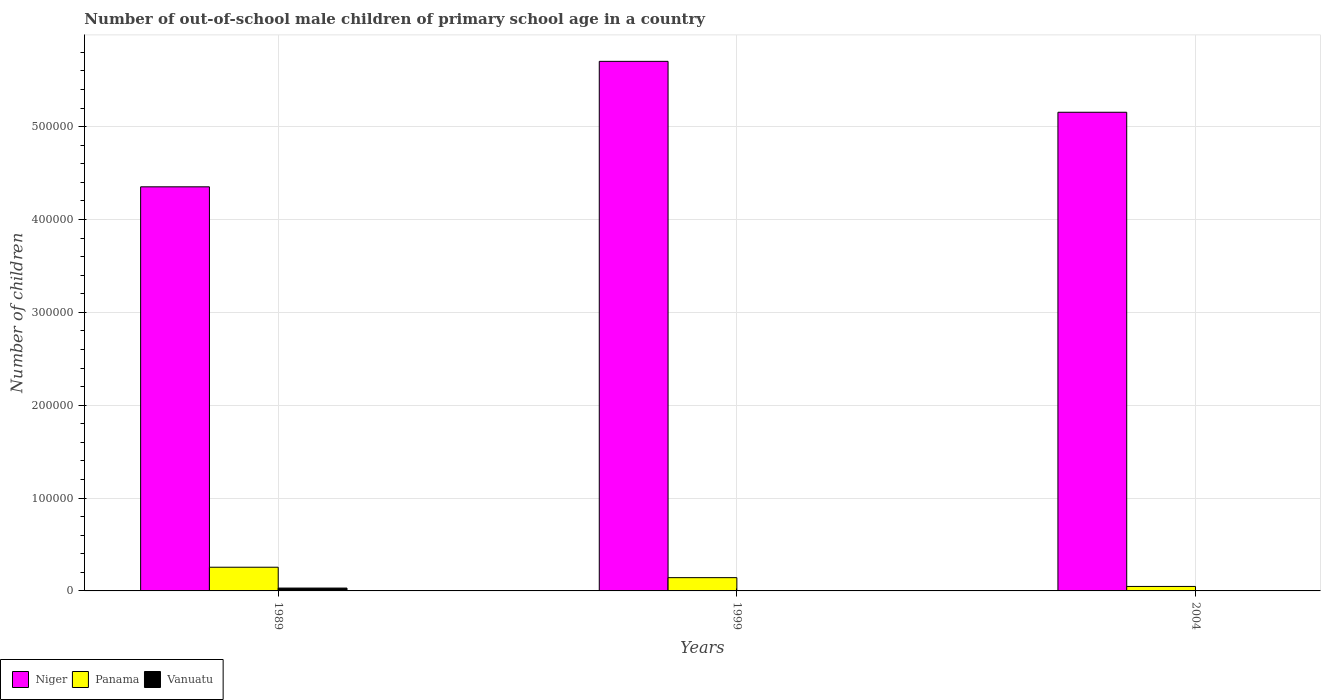How many different coloured bars are there?
Your answer should be compact. 3. How many groups of bars are there?
Offer a terse response. 3. Are the number of bars per tick equal to the number of legend labels?
Provide a succinct answer. Yes. How many bars are there on the 3rd tick from the left?
Your answer should be very brief. 3. In how many cases, is the number of bars for a given year not equal to the number of legend labels?
Keep it short and to the point. 0. What is the number of out-of-school male children in Panama in 1989?
Your answer should be compact. 2.55e+04. Across all years, what is the maximum number of out-of-school male children in Panama?
Provide a succinct answer. 2.55e+04. Across all years, what is the minimum number of out-of-school male children in Panama?
Provide a succinct answer. 4823. In which year was the number of out-of-school male children in Panama maximum?
Offer a terse response. 1989. What is the total number of out-of-school male children in Vanuatu in the graph?
Your answer should be compact. 3685. What is the difference between the number of out-of-school male children in Panama in 1989 and that in 1999?
Offer a terse response. 1.12e+04. What is the difference between the number of out-of-school male children in Niger in 1999 and the number of out-of-school male children in Vanuatu in 2004?
Offer a terse response. 5.70e+05. What is the average number of out-of-school male children in Vanuatu per year?
Give a very brief answer. 1228.33. In the year 2004, what is the difference between the number of out-of-school male children in Niger and number of out-of-school male children in Vanuatu?
Offer a very short reply. 5.15e+05. In how many years, is the number of out-of-school male children in Panama greater than 540000?
Give a very brief answer. 0. What is the ratio of the number of out-of-school male children in Vanuatu in 1999 to that in 2004?
Your response must be concise. 0.74. Is the difference between the number of out-of-school male children in Niger in 1999 and 2004 greater than the difference between the number of out-of-school male children in Vanuatu in 1999 and 2004?
Your response must be concise. Yes. What is the difference between the highest and the second highest number of out-of-school male children in Niger?
Keep it short and to the point. 5.48e+04. What is the difference between the highest and the lowest number of out-of-school male children in Niger?
Provide a short and direct response. 1.35e+05. What does the 1st bar from the left in 1989 represents?
Your response must be concise. Niger. What does the 2nd bar from the right in 1989 represents?
Give a very brief answer. Panama. How many years are there in the graph?
Offer a terse response. 3. What is the difference between two consecutive major ticks on the Y-axis?
Offer a very short reply. 1.00e+05. Does the graph contain any zero values?
Your response must be concise. No. What is the title of the graph?
Ensure brevity in your answer.  Number of out-of-school male children of primary school age in a country. Does "Small states" appear as one of the legend labels in the graph?
Your answer should be very brief. No. What is the label or title of the X-axis?
Offer a terse response. Years. What is the label or title of the Y-axis?
Offer a terse response. Number of children. What is the Number of children of Niger in 1989?
Your answer should be very brief. 4.35e+05. What is the Number of children of Panama in 1989?
Provide a short and direct response. 2.55e+04. What is the Number of children of Vanuatu in 1989?
Offer a terse response. 3073. What is the Number of children in Niger in 1999?
Give a very brief answer. 5.70e+05. What is the Number of children of Panama in 1999?
Give a very brief answer. 1.43e+04. What is the Number of children in Vanuatu in 1999?
Offer a very short reply. 261. What is the Number of children of Niger in 2004?
Provide a succinct answer. 5.16e+05. What is the Number of children in Panama in 2004?
Your answer should be compact. 4823. What is the Number of children of Vanuatu in 2004?
Give a very brief answer. 351. Across all years, what is the maximum Number of children in Niger?
Your answer should be very brief. 5.70e+05. Across all years, what is the maximum Number of children in Panama?
Keep it short and to the point. 2.55e+04. Across all years, what is the maximum Number of children of Vanuatu?
Keep it short and to the point. 3073. Across all years, what is the minimum Number of children of Niger?
Ensure brevity in your answer.  4.35e+05. Across all years, what is the minimum Number of children in Panama?
Provide a succinct answer. 4823. Across all years, what is the minimum Number of children in Vanuatu?
Your answer should be compact. 261. What is the total Number of children in Niger in the graph?
Your answer should be very brief. 1.52e+06. What is the total Number of children of Panama in the graph?
Ensure brevity in your answer.  4.46e+04. What is the total Number of children in Vanuatu in the graph?
Your response must be concise. 3685. What is the difference between the Number of children of Niger in 1989 and that in 1999?
Make the answer very short. -1.35e+05. What is the difference between the Number of children in Panama in 1989 and that in 1999?
Give a very brief answer. 1.12e+04. What is the difference between the Number of children in Vanuatu in 1989 and that in 1999?
Your answer should be very brief. 2812. What is the difference between the Number of children in Niger in 1989 and that in 2004?
Your answer should be compact. -8.03e+04. What is the difference between the Number of children of Panama in 1989 and that in 2004?
Your answer should be compact. 2.07e+04. What is the difference between the Number of children of Vanuatu in 1989 and that in 2004?
Your answer should be very brief. 2722. What is the difference between the Number of children of Niger in 1999 and that in 2004?
Ensure brevity in your answer.  5.48e+04. What is the difference between the Number of children of Panama in 1999 and that in 2004?
Provide a short and direct response. 9467. What is the difference between the Number of children of Vanuatu in 1999 and that in 2004?
Make the answer very short. -90. What is the difference between the Number of children in Niger in 1989 and the Number of children in Panama in 1999?
Offer a very short reply. 4.21e+05. What is the difference between the Number of children in Niger in 1989 and the Number of children in Vanuatu in 1999?
Make the answer very short. 4.35e+05. What is the difference between the Number of children in Panama in 1989 and the Number of children in Vanuatu in 1999?
Your answer should be very brief. 2.53e+04. What is the difference between the Number of children of Niger in 1989 and the Number of children of Panama in 2004?
Provide a short and direct response. 4.30e+05. What is the difference between the Number of children of Niger in 1989 and the Number of children of Vanuatu in 2004?
Make the answer very short. 4.35e+05. What is the difference between the Number of children in Panama in 1989 and the Number of children in Vanuatu in 2004?
Provide a short and direct response. 2.52e+04. What is the difference between the Number of children in Niger in 1999 and the Number of children in Panama in 2004?
Make the answer very short. 5.66e+05. What is the difference between the Number of children in Niger in 1999 and the Number of children in Vanuatu in 2004?
Your answer should be very brief. 5.70e+05. What is the difference between the Number of children of Panama in 1999 and the Number of children of Vanuatu in 2004?
Your answer should be very brief. 1.39e+04. What is the average Number of children of Niger per year?
Make the answer very short. 5.07e+05. What is the average Number of children in Panama per year?
Ensure brevity in your answer.  1.49e+04. What is the average Number of children of Vanuatu per year?
Provide a short and direct response. 1228.33. In the year 1989, what is the difference between the Number of children of Niger and Number of children of Panama?
Offer a very short reply. 4.10e+05. In the year 1989, what is the difference between the Number of children of Niger and Number of children of Vanuatu?
Provide a succinct answer. 4.32e+05. In the year 1989, what is the difference between the Number of children of Panama and Number of children of Vanuatu?
Offer a terse response. 2.24e+04. In the year 1999, what is the difference between the Number of children of Niger and Number of children of Panama?
Your answer should be compact. 5.56e+05. In the year 1999, what is the difference between the Number of children of Niger and Number of children of Vanuatu?
Ensure brevity in your answer.  5.70e+05. In the year 1999, what is the difference between the Number of children in Panama and Number of children in Vanuatu?
Your answer should be compact. 1.40e+04. In the year 2004, what is the difference between the Number of children of Niger and Number of children of Panama?
Provide a succinct answer. 5.11e+05. In the year 2004, what is the difference between the Number of children of Niger and Number of children of Vanuatu?
Your answer should be very brief. 5.15e+05. In the year 2004, what is the difference between the Number of children in Panama and Number of children in Vanuatu?
Your answer should be very brief. 4472. What is the ratio of the Number of children of Niger in 1989 to that in 1999?
Provide a short and direct response. 0.76. What is the ratio of the Number of children in Panama in 1989 to that in 1999?
Offer a very short reply. 1.79. What is the ratio of the Number of children in Vanuatu in 1989 to that in 1999?
Provide a succinct answer. 11.77. What is the ratio of the Number of children of Niger in 1989 to that in 2004?
Give a very brief answer. 0.84. What is the ratio of the Number of children of Panama in 1989 to that in 2004?
Give a very brief answer. 5.29. What is the ratio of the Number of children of Vanuatu in 1989 to that in 2004?
Make the answer very short. 8.76. What is the ratio of the Number of children of Niger in 1999 to that in 2004?
Ensure brevity in your answer.  1.11. What is the ratio of the Number of children of Panama in 1999 to that in 2004?
Provide a short and direct response. 2.96. What is the ratio of the Number of children of Vanuatu in 1999 to that in 2004?
Keep it short and to the point. 0.74. What is the difference between the highest and the second highest Number of children in Niger?
Offer a terse response. 5.48e+04. What is the difference between the highest and the second highest Number of children in Panama?
Your response must be concise. 1.12e+04. What is the difference between the highest and the second highest Number of children of Vanuatu?
Your answer should be very brief. 2722. What is the difference between the highest and the lowest Number of children in Niger?
Your response must be concise. 1.35e+05. What is the difference between the highest and the lowest Number of children of Panama?
Offer a terse response. 2.07e+04. What is the difference between the highest and the lowest Number of children in Vanuatu?
Keep it short and to the point. 2812. 